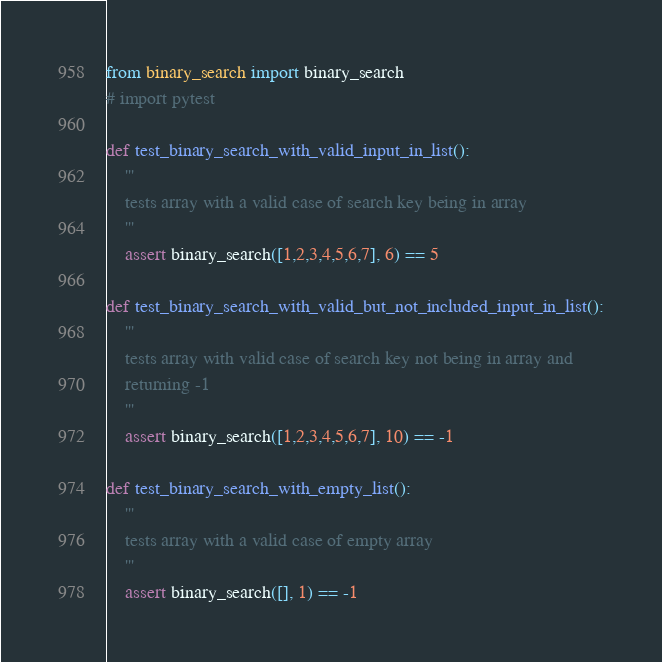<code> <loc_0><loc_0><loc_500><loc_500><_Python_>from binary_search import binary_search
# import pytest

def test_binary_search_with_valid_input_in_list():
    '''
    tests array with a valid case of search key being in array
    '''
    assert binary_search([1,2,3,4,5,6,7], 6) == 5

def test_binary_search_with_valid_but_not_included_input_in_list():
    '''
    tests array with valid case of search key not being in array and 
    returning -1
    '''
    assert binary_search([1,2,3,4,5,6,7], 10) == -1

def test_binary_search_with_empty_list():
    '''
    tests array with a valid case of empty array
    '''
    assert binary_search([], 1) == -1
</code> 